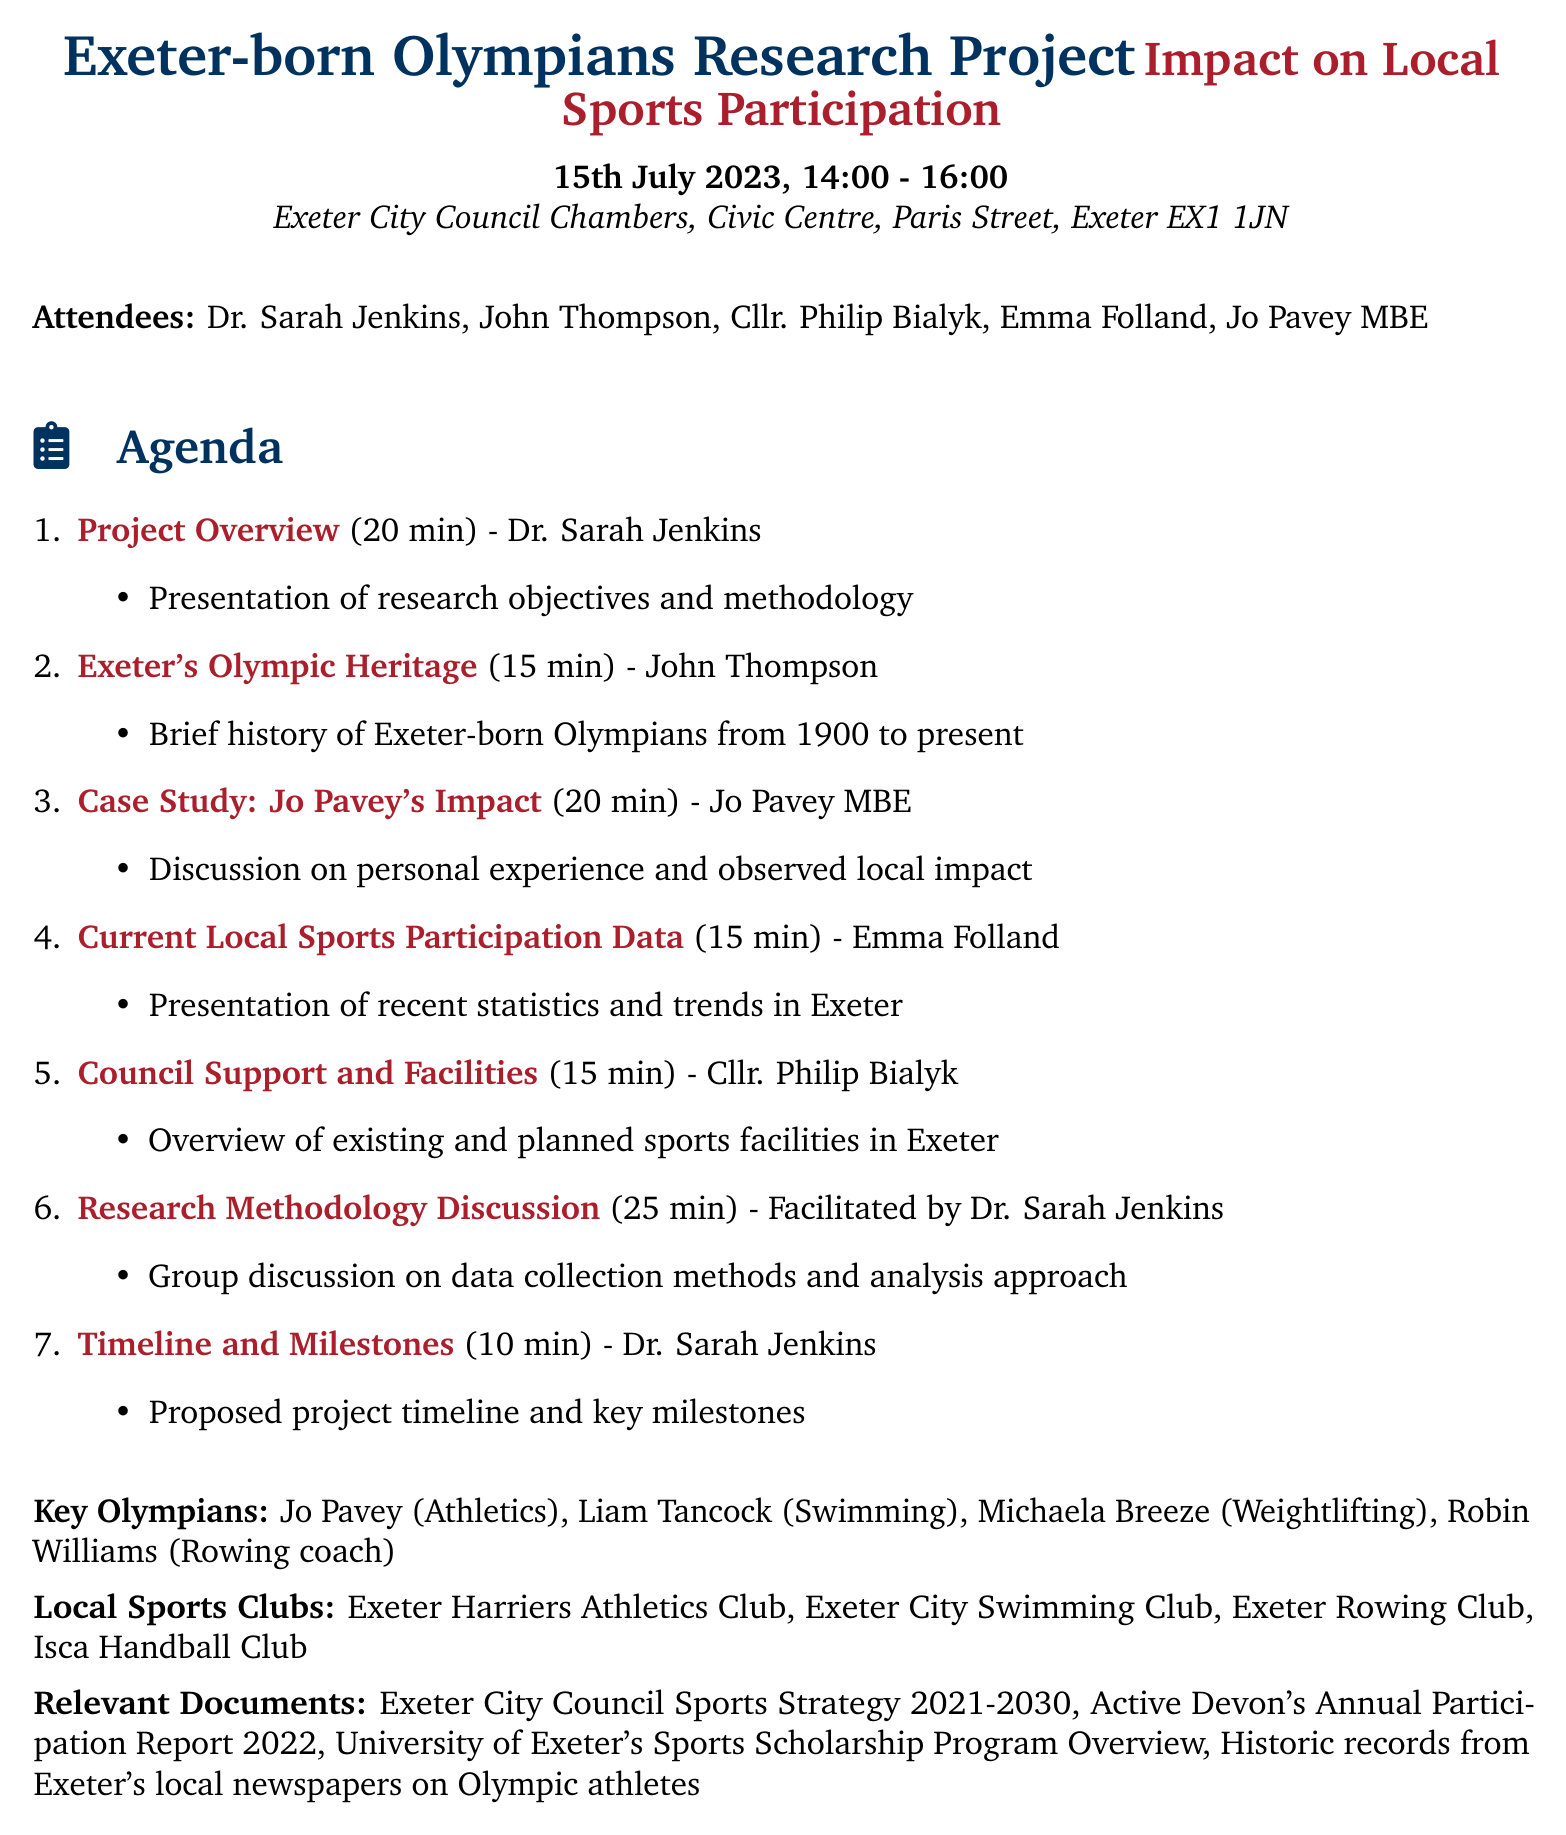What is the title of the meeting? The title of the meeting is specified at the beginning of the document, which is "Exeter-born Olympians Research Project: Impact on Local Sports Participation."
Answer: Exeter-born Olympians Research Project: Impact on Local Sports Participation Who is the presenter for the "Project Overview"? The document lists the presenter for the "Project Overview" section, which is Dr. Sarah Jenkins.
Answer: Dr. Sarah Jenkins What is the duration of the "Case Study: Jo Pavey's Impact"? The document specifies the duration of "Case Study: Jo Pavey's Impact," which is 20 minutes.
Answer: 20 minutes Which local sports club is mentioned first in the list? The first local sports club mentioned in the document is "Exeter Harriers Athletics Club."
Answer: Exeter Harriers Athletics Club How long is allocated for the group discussion on research methodology? The document indicates that 25 minutes are allocated for the group discussion on research methodology.
Answer: 25 minutes What is the role of Jo Pavey at the meeting? Jo Pavey is listed as a former Olympian from Exeter, presenting a case study during the meeting.
Answer: Former Olympian from Exeter What are the proposed project timeline and key milestones discussed in? The timeline and milestones are discussed in the section presented by Dr. Sarah Jenkins.
Answer: Dr. Sarah Jenkins Which document outlines Exeter City Council's sports strategy? The relevant document that outlines the sports strategy is titled "Exeter City Council Sports Strategy 2021-2030."
Answer: Exeter City Council Sports Strategy 2021-2030 